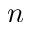Convert formula to latex. <formula><loc_0><loc_0><loc_500><loc_500>n</formula> 